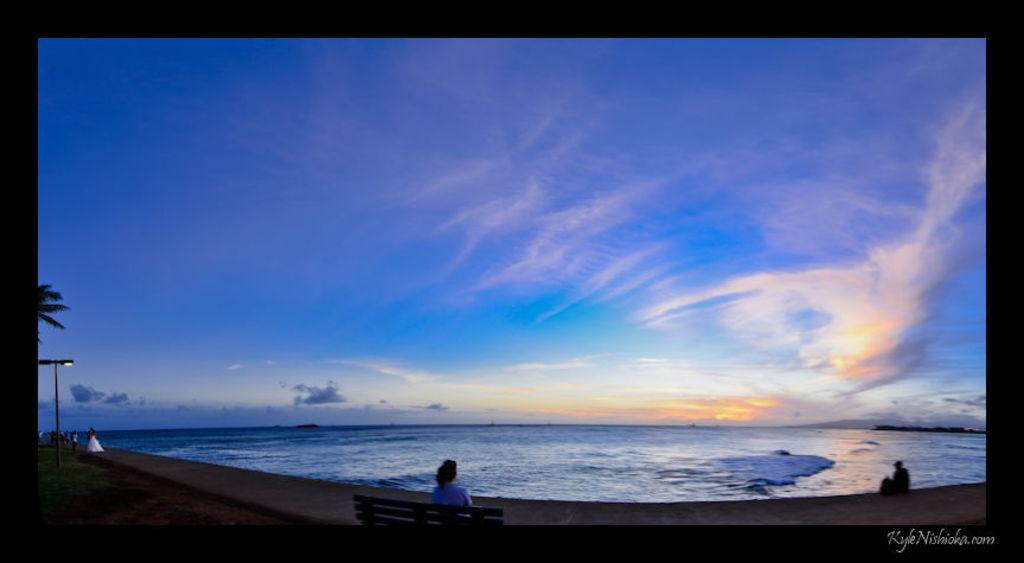<image>
Create a compact narrative representing the image presented. A picture of a beach by Kyle Nishioka. 